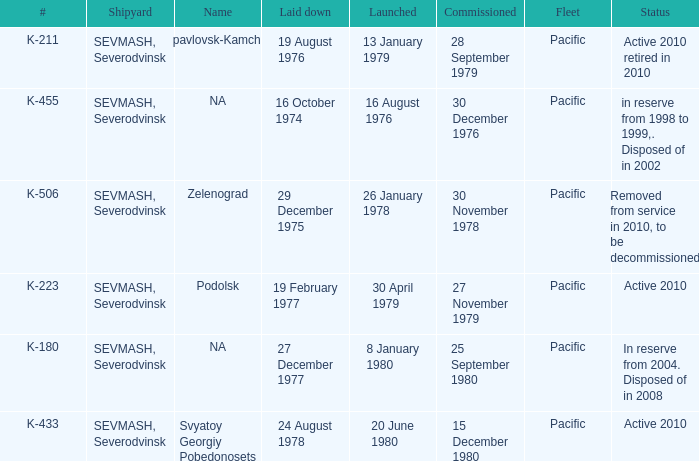What is the status of vessel number K-223? Active 2010. 